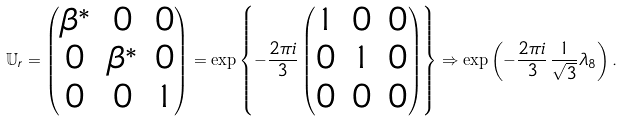Convert formula to latex. <formula><loc_0><loc_0><loc_500><loc_500>\mathbb { U } _ { r } = \begin{pmatrix} \beta ^ { * } & 0 & 0 \\ 0 & \beta ^ { * } & 0 \\ 0 & 0 & 1 \end{pmatrix} = \exp \left \{ - \frac { 2 \pi i } { 3 } \begin{pmatrix} 1 & 0 & 0 \\ 0 & 1 & 0 \\ 0 & 0 & 0 \end{pmatrix} \right \} \Rightarrow \exp \left ( - \frac { 2 \pi i } { 3 } \, \frac { 1 } { \sqrt { 3 } } \lambda _ { 8 } \right ) .</formula> 